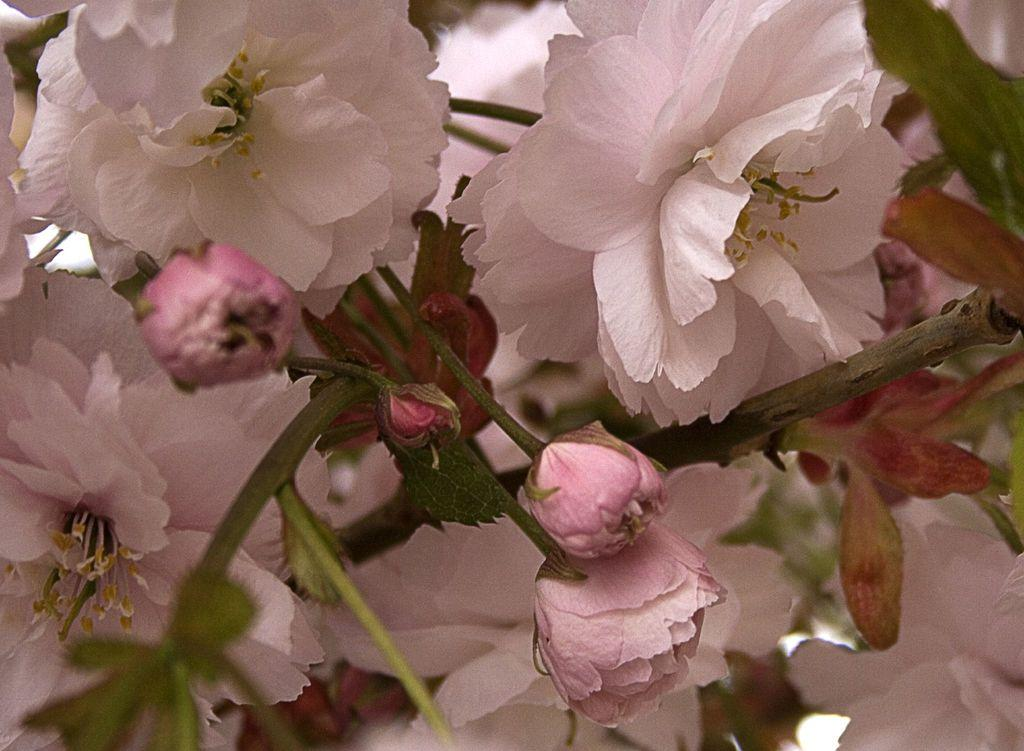What is the main subject of the image? The main subject of the image is a group of flowers. Where are the flowers located in the image? The flowers are on the stems of plants. What shape is the rain in the image? There is no rain present in the image. What type of pot is the flowers placed in? The provided facts do not mention a pot, so we cannot determine if the flowers are in a pot or not. 